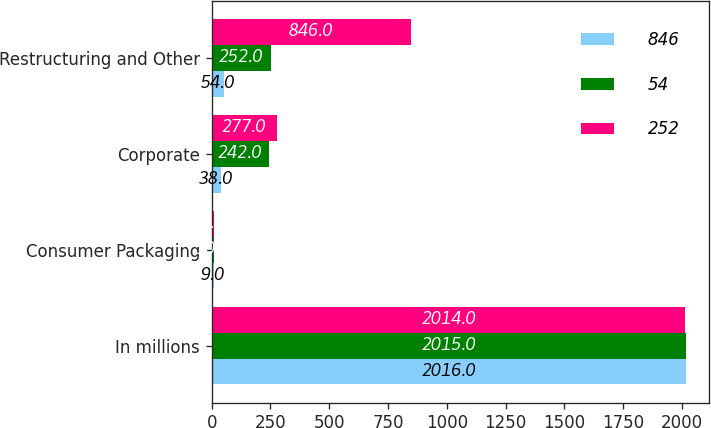Convert chart. <chart><loc_0><loc_0><loc_500><loc_500><stacked_bar_chart><ecel><fcel>In millions<fcel>Consumer Packaging<fcel>Corporate<fcel>Restructuring and Other<nl><fcel>846<fcel>2016<fcel>9<fcel>38<fcel>54<nl><fcel>54<fcel>2015<fcel>10<fcel>242<fcel>252<nl><fcel>252<fcel>2014<fcel>8<fcel>277<fcel>846<nl></chart> 